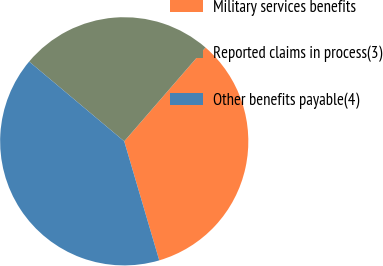Convert chart to OTSL. <chart><loc_0><loc_0><loc_500><loc_500><pie_chart><fcel>Military services benefits<fcel>Reported claims in process(3)<fcel>Other benefits payable(4)<nl><fcel>34.08%<fcel>25.26%<fcel>40.66%<nl></chart> 